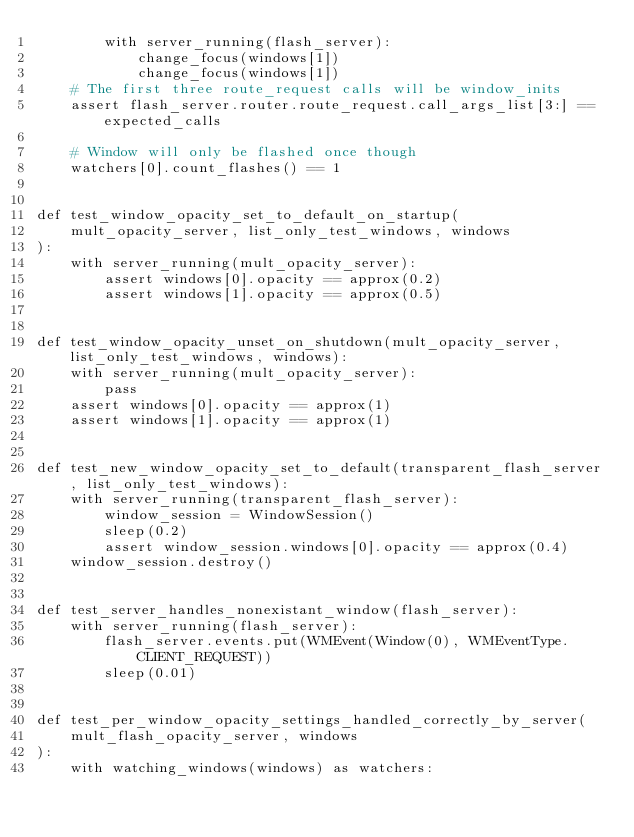Convert code to text. <code><loc_0><loc_0><loc_500><loc_500><_Python_>        with server_running(flash_server):
            change_focus(windows[1])
            change_focus(windows[1])
    # The first three route_request calls will be window_inits
    assert flash_server.router.route_request.call_args_list[3:] == expected_calls

    # Window will only be flashed once though
    watchers[0].count_flashes() == 1


def test_window_opacity_set_to_default_on_startup(
    mult_opacity_server, list_only_test_windows, windows
):
    with server_running(mult_opacity_server):
        assert windows[0].opacity == approx(0.2)
        assert windows[1].opacity == approx(0.5)


def test_window_opacity_unset_on_shutdown(mult_opacity_server, list_only_test_windows, windows):
    with server_running(mult_opacity_server):
        pass
    assert windows[0].opacity == approx(1)
    assert windows[1].opacity == approx(1)


def test_new_window_opacity_set_to_default(transparent_flash_server, list_only_test_windows):
    with server_running(transparent_flash_server):
        window_session = WindowSession()
        sleep(0.2)
        assert window_session.windows[0].opacity == approx(0.4)
    window_session.destroy()


def test_server_handles_nonexistant_window(flash_server):
    with server_running(flash_server):
        flash_server.events.put(WMEvent(Window(0), WMEventType.CLIENT_REQUEST))
        sleep(0.01)


def test_per_window_opacity_settings_handled_correctly_by_server(
    mult_flash_opacity_server, windows
):
    with watching_windows(windows) as watchers:</code> 